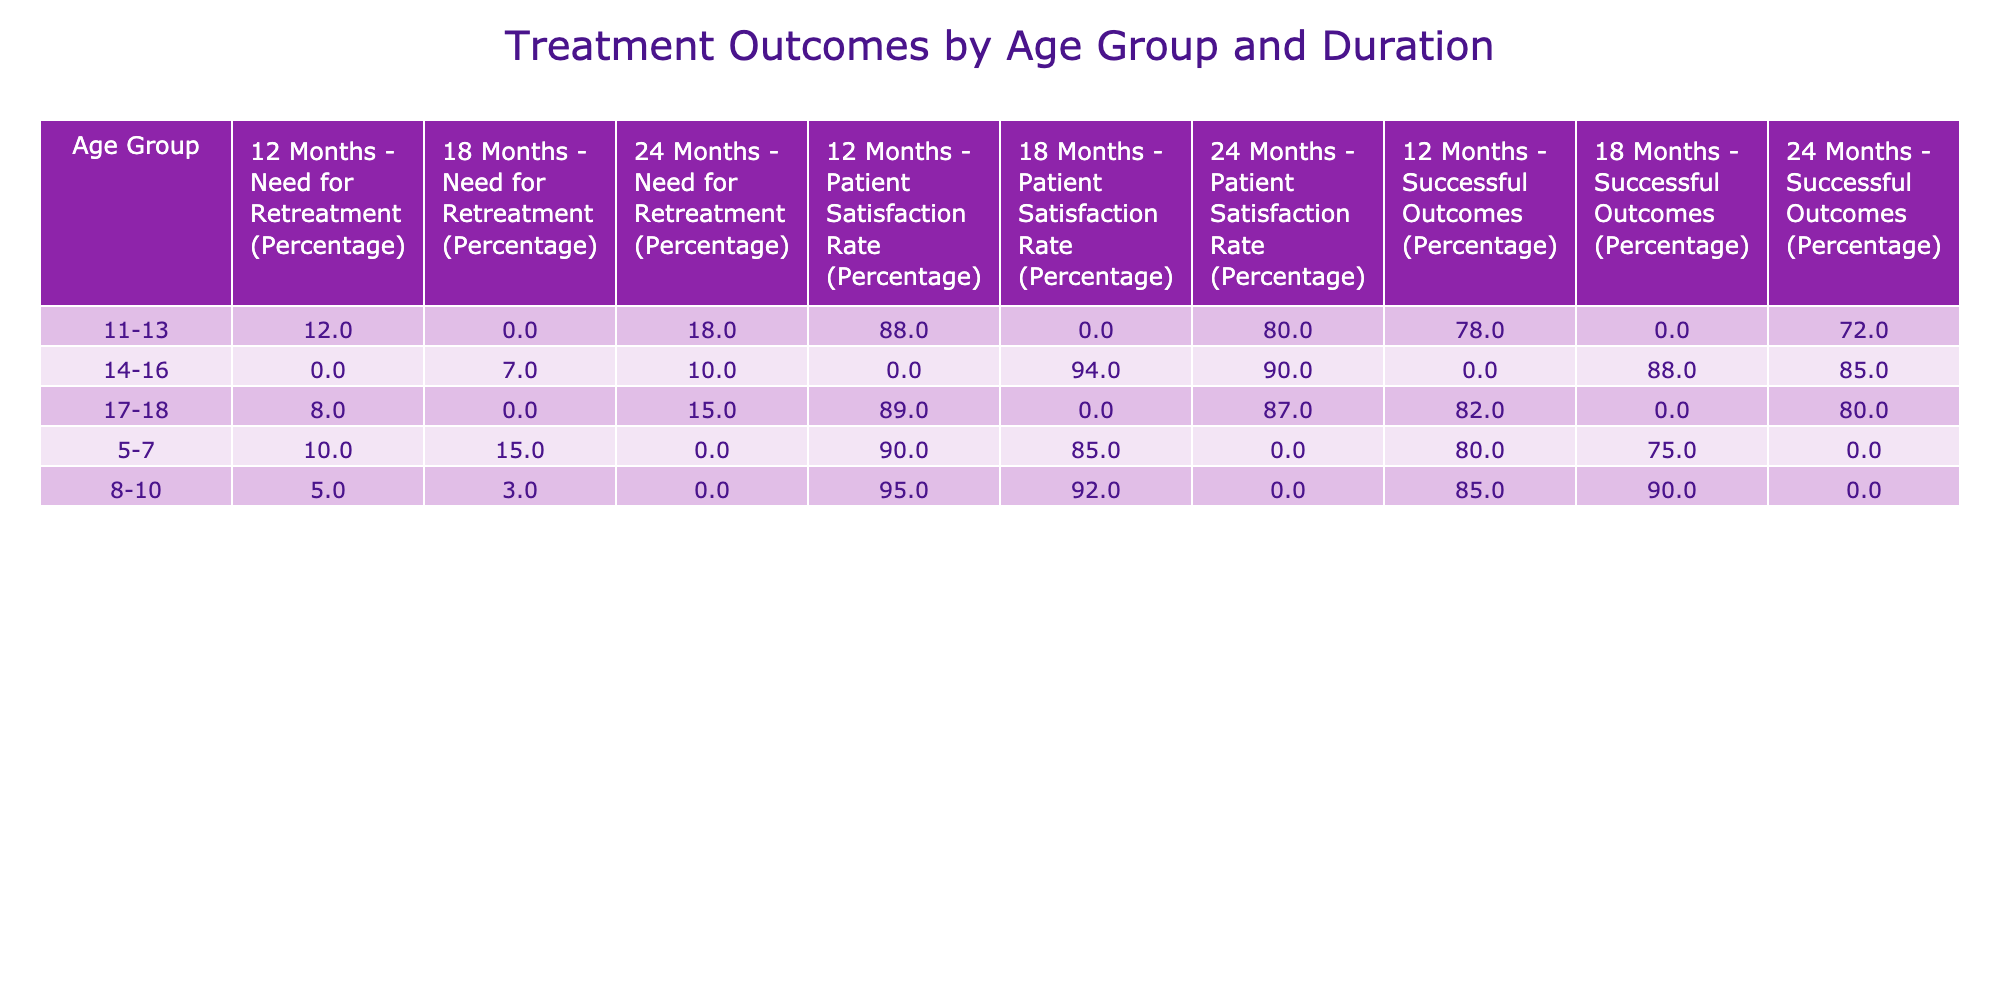What is the successful outcomes percentage for the age group 5-7 with a treatment duration of 12 months? According to the table, the age group 5-7 and treatment duration of 12 months has a successful outcomes percentage of 80.
Answer: 80 Which age group had the highest patient satisfaction rate for a treatment duration of 18 months? The table indicates that the age group 8-10 has a patient satisfaction rate of 92 for an 18-month treatment duration, which is the highest among the groups.
Answer: 92 What is the average need for retreatment percentage for the 14-16 age group? The need for retreatment percentages for the 14-16 age group are 7 and 10. To calculate the average, sum the percentages (7 + 10) = 17, and divide by the number of entries (2). Thus, 17/2 = 8.5.
Answer: 8.5 Is the patient satisfaction rate for the age group 11-13 higher than that for the age group 5-7 at a 12-month treatment duration? The patient satisfaction rate for age group 11-13 at 12 months is 88, while for age group 5-7 at the same treatment duration, it is 90. Since 88 is lower than 90, the statement is false.
Answer: No How does the successful outcomes percentage for the 12-month treatment duration compare between age groups 8-10 and 11-13? For age group 8-10, the successful outcomes percentage at 12 months is 85, while for age group 11-13, it is 78. The successful outcomes percentage for age group 8-10 is higher than that of age group 11-13 by a difference of 7 (85 - 78).
Answer: 7 